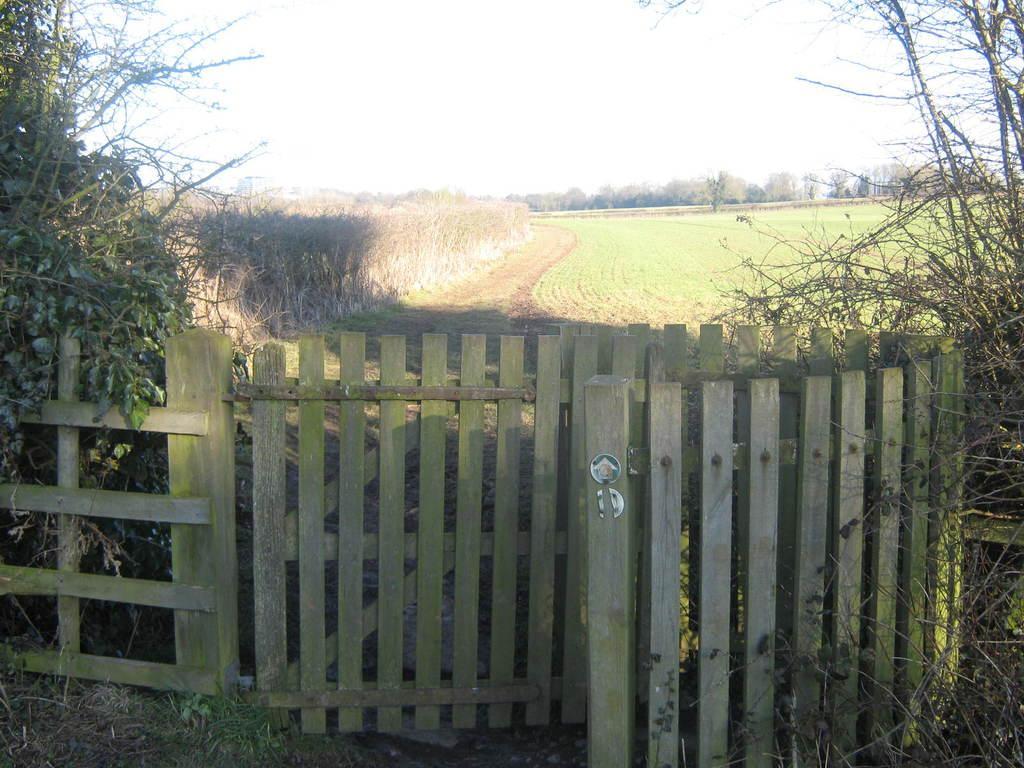Could you give a brief overview of what you see in this image? In this picture we can see the wooden gate in the front side. Behind there is a agriculture grass field. On the left side there is some dry wheat plants. In the background we can see some trees. 